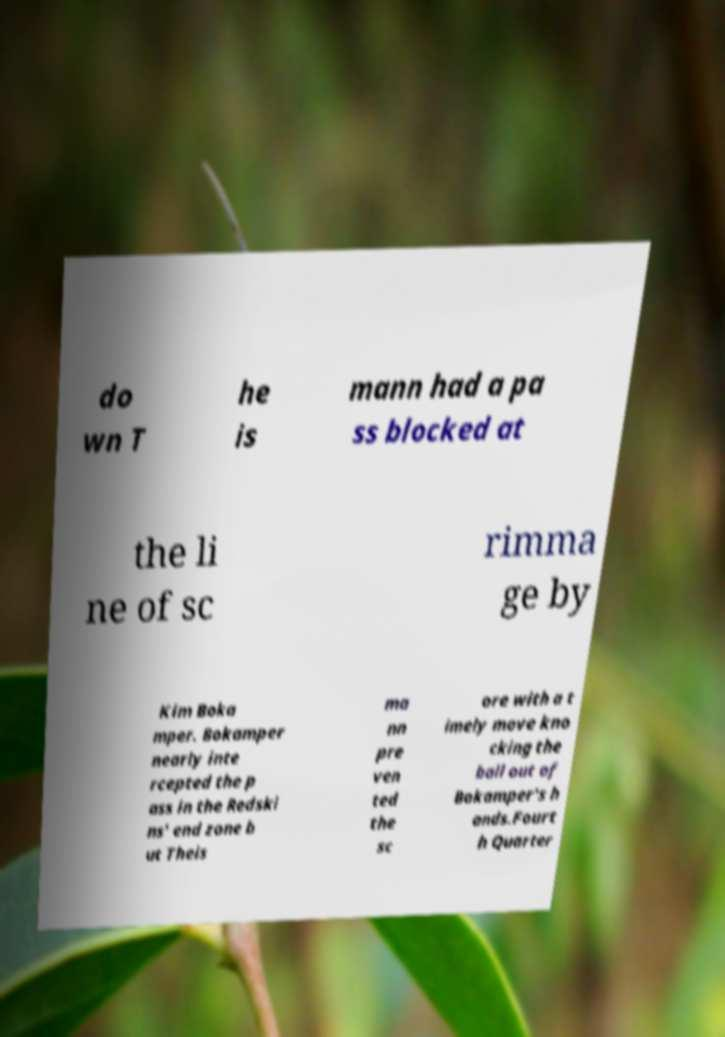What messages or text are displayed in this image? I need them in a readable, typed format. do wn T he is mann had a pa ss blocked at the li ne of sc rimma ge by Kim Boka mper. Bokamper nearly inte rcepted the p ass in the Redski ns' end zone b ut Theis ma nn pre ven ted the sc ore with a t imely move kno cking the ball out of Bokamper's h ands.Fourt h Quarter 